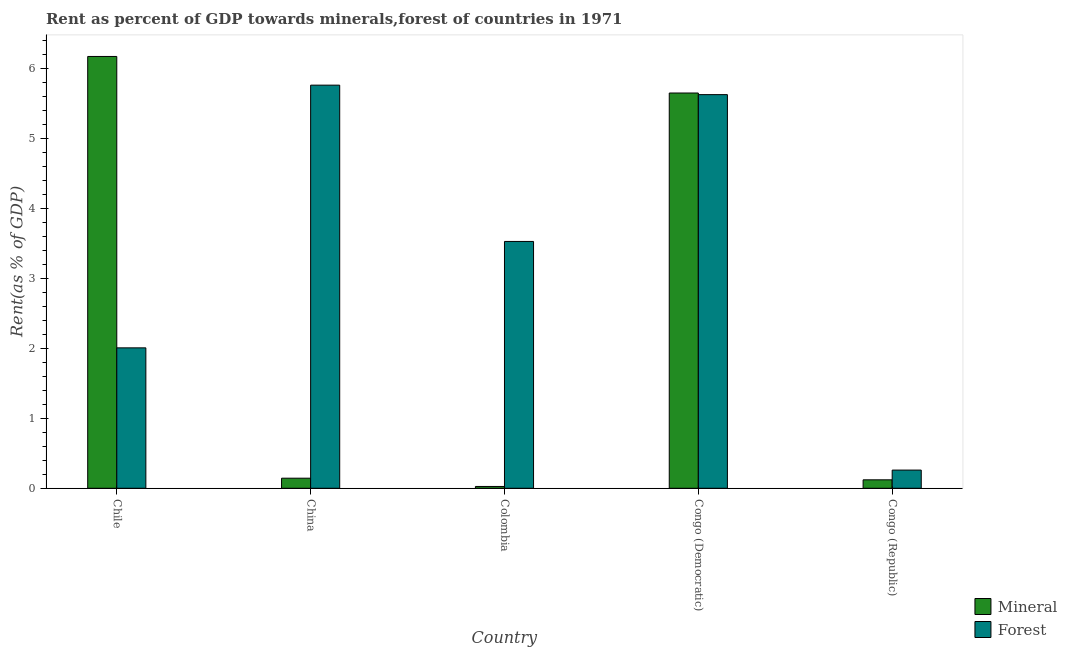How many different coloured bars are there?
Keep it short and to the point. 2. Are the number of bars per tick equal to the number of legend labels?
Your answer should be very brief. Yes. Are the number of bars on each tick of the X-axis equal?
Keep it short and to the point. Yes. How many bars are there on the 4th tick from the right?
Offer a very short reply. 2. What is the label of the 4th group of bars from the left?
Offer a terse response. Congo (Democratic). In how many cases, is the number of bars for a given country not equal to the number of legend labels?
Keep it short and to the point. 0. What is the mineral rent in Colombia?
Keep it short and to the point. 0.03. Across all countries, what is the maximum forest rent?
Give a very brief answer. 5.77. Across all countries, what is the minimum mineral rent?
Your answer should be compact. 0.03. In which country was the mineral rent minimum?
Provide a short and direct response. Colombia. What is the total forest rent in the graph?
Offer a terse response. 17.19. What is the difference between the forest rent in China and that in Congo (Democratic)?
Your response must be concise. 0.14. What is the difference between the forest rent in Congo (Republic) and the mineral rent in Chile?
Offer a very short reply. -5.92. What is the average forest rent per country?
Make the answer very short. 3.44. What is the difference between the mineral rent and forest rent in Colombia?
Provide a succinct answer. -3.5. In how many countries, is the forest rent greater than 6.2 %?
Keep it short and to the point. 0. What is the ratio of the forest rent in China to that in Colombia?
Offer a terse response. 1.63. Is the forest rent in Chile less than that in Congo (Democratic)?
Your answer should be compact. Yes. Is the difference between the forest rent in China and Congo (Democratic) greater than the difference between the mineral rent in China and Congo (Democratic)?
Ensure brevity in your answer.  Yes. What is the difference between the highest and the second highest forest rent?
Keep it short and to the point. 0.14. What is the difference between the highest and the lowest mineral rent?
Your answer should be compact. 6.15. In how many countries, is the mineral rent greater than the average mineral rent taken over all countries?
Provide a short and direct response. 2. What does the 2nd bar from the left in China represents?
Your response must be concise. Forest. What does the 2nd bar from the right in Congo (Republic) represents?
Provide a short and direct response. Mineral. How many bars are there?
Give a very brief answer. 10. How many countries are there in the graph?
Your response must be concise. 5. What is the difference between two consecutive major ticks on the Y-axis?
Provide a succinct answer. 1. Does the graph contain grids?
Your response must be concise. No. Where does the legend appear in the graph?
Your answer should be compact. Bottom right. What is the title of the graph?
Provide a short and direct response. Rent as percent of GDP towards minerals,forest of countries in 1971. What is the label or title of the X-axis?
Ensure brevity in your answer.  Country. What is the label or title of the Y-axis?
Make the answer very short. Rent(as % of GDP). What is the Rent(as % of GDP) of Mineral in Chile?
Your answer should be compact. 6.18. What is the Rent(as % of GDP) of Forest in Chile?
Make the answer very short. 2.01. What is the Rent(as % of GDP) in Mineral in China?
Offer a very short reply. 0.14. What is the Rent(as % of GDP) of Forest in China?
Offer a very short reply. 5.77. What is the Rent(as % of GDP) of Mineral in Colombia?
Keep it short and to the point. 0.03. What is the Rent(as % of GDP) in Forest in Colombia?
Provide a succinct answer. 3.53. What is the Rent(as % of GDP) of Mineral in Congo (Democratic)?
Your response must be concise. 5.65. What is the Rent(as % of GDP) in Forest in Congo (Democratic)?
Offer a terse response. 5.63. What is the Rent(as % of GDP) in Mineral in Congo (Republic)?
Offer a very short reply. 0.12. What is the Rent(as % of GDP) of Forest in Congo (Republic)?
Your answer should be compact. 0.26. Across all countries, what is the maximum Rent(as % of GDP) in Mineral?
Offer a very short reply. 6.18. Across all countries, what is the maximum Rent(as % of GDP) in Forest?
Your response must be concise. 5.77. Across all countries, what is the minimum Rent(as % of GDP) in Mineral?
Your answer should be very brief. 0.03. Across all countries, what is the minimum Rent(as % of GDP) in Forest?
Your answer should be very brief. 0.26. What is the total Rent(as % of GDP) in Mineral in the graph?
Your answer should be compact. 12.12. What is the total Rent(as % of GDP) in Forest in the graph?
Offer a very short reply. 17.19. What is the difference between the Rent(as % of GDP) of Mineral in Chile and that in China?
Provide a succinct answer. 6.03. What is the difference between the Rent(as % of GDP) of Forest in Chile and that in China?
Give a very brief answer. -3.76. What is the difference between the Rent(as % of GDP) of Mineral in Chile and that in Colombia?
Provide a succinct answer. 6.15. What is the difference between the Rent(as % of GDP) of Forest in Chile and that in Colombia?
Give a very brief answer. -1.52. What is the difference between the Rent(as % of GDP) in Mineral in Chile and that in Congo (Democratic)?
Make the answer very short. 0.52. What is the difference between the Rent(as % of GDP) in Forest in Chile and that in Congo (Democratic)?
Keep it short and to the point. -3.62. What is the difference between the Rent(as % of GDP) in Mineral in Chile and that in Congo (Republic)?
Your answer should be compact. 6.05. What is the difference between the Rent(as % of GDP) of Forest in Chile and that in Congo (Republic)?
Make the answer very short. 1.75. What is the difference between the Rent(as % of GDP) of Mineral in China and that in Colombia?
Make the answer very short. 0.12. What is the difference between the Rent(as % of GDP) of Forest in China and that in Colombia?
Provide a succinct answer. 2.24. What is the difference between the Rent(as % of GDP) in Mineral in China and that in Congo (Democratic)?
Provide a succinct answer. -5.51. What is the difference between the Rent(as % of GDP) in Forest in China and that in Congo (Democratic)?
Ensure brevity in your answer.  0.14. What is the difference between the Rent(as % of GDP) in Mineral in China and that in Congo (Republic)?
Your answer should be very brief. 0.02. What is the difference between the Rent(as % of GDP) of Forest in China and that in Congo (Republic)?
Your answer should be very brief. 5.5. What is the difference between the Rent(as % of GDP) in Mineral in Colombia and that in Congo (Democratic)?
Your response must be concise. -5.63. What is the difference between the Rent(as % of GDP) of Forest in Colombia and that in Congo (Democratic)?
Keep it short and to the point. -2.1. What is the difference between the Rent(as % of GDP) of Mineral in Colombia and that in Congo (Republic)?
Provide a short and direct response. -0.09. What is the difference between the Rent(as % of GDP) in Forest in Colombia and that in Congo (Republic)?
Give a very brief answer. 3.27. What is the difference between the Rent(as % of GDP) of Mineral in Congo (Democratic) and that in Congo (Republic)?
Your answer should be compact. 5.53. What is the difference between the Rent(as % of GDP) in Forest in Congo (Democratic) and that in Congo (Republic)?
Offer a terse response. 5.37. What is the difference between the Rent(as % of GDP) in Mineral in Chile and the Rent(as % of GDP) in Forest in China?
Make the answer very short. 0.41. What is the difference between the Rent(as % of GDP) in Mineral in Chile and the Rent(as % of GDP) in Forest in Colombia?
Keep it short and to the point. 2.65. What is the difference between the Rent(as % of GDP) in Mineral in Chile and the Rent(as % of GDP) in Forest in Congo (Democratic)?
Your answer should be compact. 0.55. What is the difference between the Rent(as % of GDP) in Mineral in Chile and the Rent(as % of GDP) in Forest in Congo (Republic)?
Make the answer very short. 5.92. What is the difference between the Rent(as % of GDP) in Mineral in China and the Rent(as % of GDP) in Forest in Colombia?
Your answer should be very brief. -3.39. What is the difference between the Rent(as % of GDP) in Mineral in China and the Rent(as % of GDP) in Forest in Congo (Democratic)?
Your answer should be compact. -5.49. What is the difference between the Rent(as % of GDP) in Mineral in China and the Rent(as % of GDP) in Forest in Congo (Republic)?
Keep it short and to the point. -0.12. What is the difference between the Rent(as % of GDP) in Mineral in Colombia and the Rent(as % of GDP) in Forest in Congo (Democratic)?
Ensure brevity in your answer.  -5.6. What is the difference between the Rent(as % of GDP) in Mineral in Colombia and the Rent(as % of GDP) in Forest in Congo (Republic)?
Provide a succinct answer. -0.23. What is the difference between the Rent(as % of GDP) in Mineral in Congo (Democratic) and the Rent(as % of GDP) in Forest in Congo (Republic)?
Your answer should be compact. 5.39. What is the average Rent(as % of GDP) in Mineral per country?
Keep it short and to the point. 2.42. What is the average Rent(as % of GDP) in Forest per country?
Your answer should be very brief. 3.44. What is the difference between the Rent(as % of GDP) of Mineral and Rent(as % of GDP) of Forest in Chile?
Give a very brief answer. 4.17. What is the difference between the Rent(as % of GDP) of Mineral and Rent(as % of GDP) of Forest in China?
Your answer should be very brief. -5.62. What is the difference between the Rent(as % of GDP) of Mineral and Rent(as % of GDP) of Forest in Colombia?
Keep it short and to the point. -3.5. What is the difference between the Rent(as % of GDP) of Mineral and Rent(as % of GDP) of Forest in Congo (Democratic)?
Give a very brief answer. 0.02. What is the difference between the Rent(as % of GDP) in Mineral and Rent(as % of GDP) in Forest in Congo (Republic)?
Your response must be concise. -0.14. What is the ratio of the Rent(as % of GDP) of Mineral in Chile to that in China?
Ensure brevity in your answer.  42.82. What is the ratio of the Rent(as % of GDP) of Forest in Chile to that in China?
Your answer should be very brief. 0.35. What is the ratio of the Rent(as % of GDP) of Mineral in Chile to that in Colombia?
Provide a short and direct response. 236.61. What is the ratio of the Rent(as % of GDP) in Forest in Chile to that in Colombia?
Offer a very short reply. 0.57. What is the ratio of the Rent(as % of GDP) in Mineral in Chile to that in Congo (Democratic)?
Your response must be concise. 1.09. What is the ratio of the Rent(as % of GDP) in Forest in Chile to that in Congo (Democratic)?
Offer a terse response. 0.36. What is the ratio of the Rent(as % of GDP) of Mineral in Chile to that in Congo (Republic)?
Provide a succinct answer. 51.05. What is the ratio of the Rent(as % of GDP) in Forest in Chile to that in Congo (Republic)?
Make the answer very short. 7.72. What is the ratio of the Rent(as % of GDP) in Mineral in China to that in Colombia?
Provide a succinct answer. 5.53. What is the ratio of the Rent(as % of GDP) of Forest in China to that in Colombia?
Your answer should be very brief. 1.63. What is the ratio of the Rent(as % of GDP) of Mineral in China to that in Congo (Democratic)?
Your answer should be compact. 0.03. What is the ratio of the Rent(as % of GDP) in Forest in China to that in Congo (Democratic)?
Your answer should be very brief. 1.02. What is the ratio of the Rent(as % of GDP) in Mineral in China to that in Congo (Republic)?
Keep it short and to the point. 1.19. What is the ratio of the Rent(as % of GDP) in Forest in China to that in Congo (Republic)?
Give a very brief answer. 22.15. What is the ratio of the Rent(as % of GDP) of Mineral in Colombia to that in Congo (Democratic)?
Keep it short and to the point. 0. What is the ratio of the Rent(as % of GDP) in Forest in Colombia to that in Congo (Democratic)?
Offer a very short reply. 0.63. What is the ratio of the Rent(as % of GDP) of Mineral in Colombia to that in Congo (Republic)?
Provide a short and direct response. 0.22. What is the ratio of the Rent(as % of GDP) of Forest in Colombia to that in Congo (Republic)?
Ensure brevity in your answer.  13.56. What is the ratio of the Rent(as % of GDP) of Mineral in Congo (Democratic) to that in Congo (Republic)?
Keep it short and to the point. 46.73. What is the ratio of the Rent(as % of GDP) of Forest in Congo (Democratic) to that in Congo (Republic)?
Make the answer very short. 21.63. What is the difference between the highest and the second highest Rent(as % of GDP) in Mineral?
Ensure brevity in your answer.  0.52. What is the difference between the highest and the second highest Rent(as % of GDP) in Forest?
Provide a succinct answer. 0.14. What is the difference between the highest and the lowest Rent(as % of GDP) of Mineral?
Keep it short and to the point. 6.15. What is the difference between the highest and the lowest Rent(as % of GDP) of Forest?
Offer a very short reply. 5.5. 